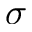<formula> <loc_0><loc_0><loc_500><loc_500>\sigma</formula> 